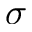<formula> <loc_0><loc_0><loc_500><loc_500>\sigma</formula> 